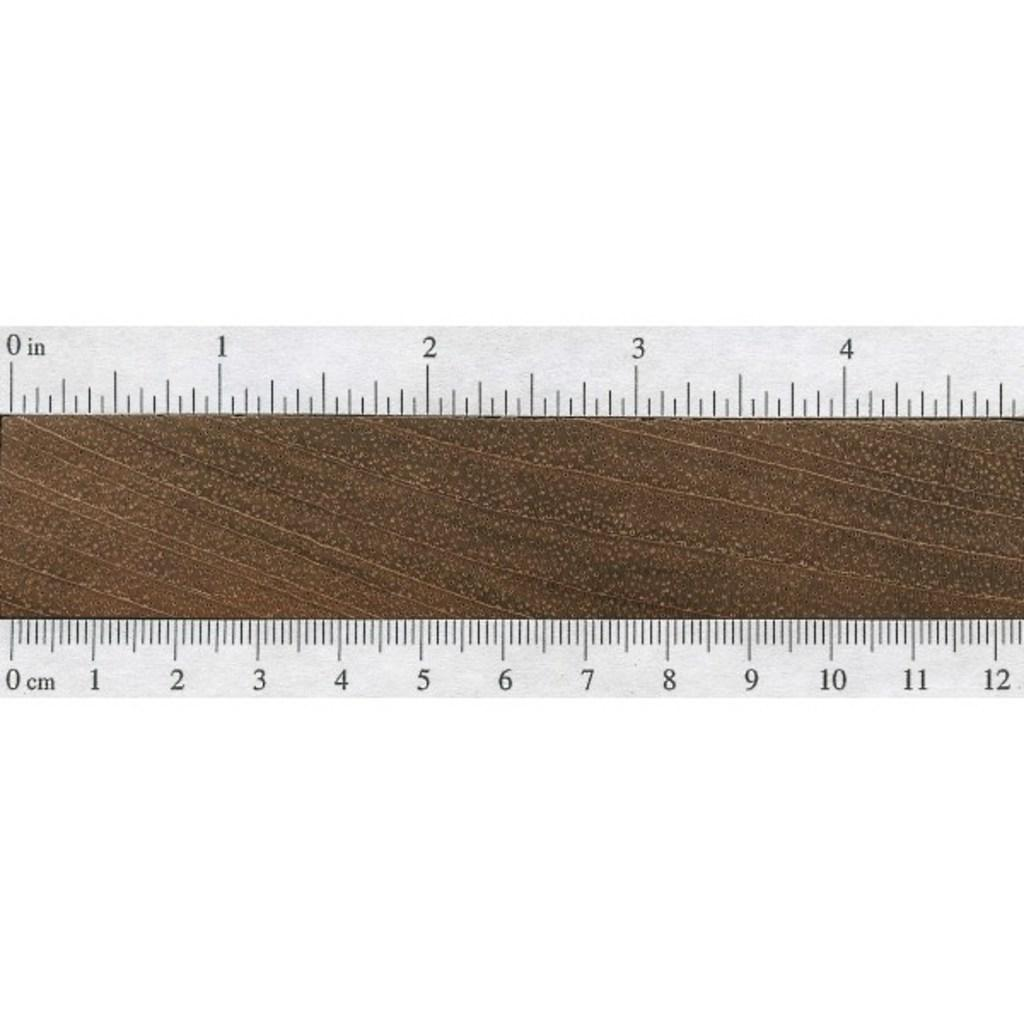<image>
Give a short and clear explanation of the subsequent image. A ruler displays 0 in and 0 cm on the left edge. 